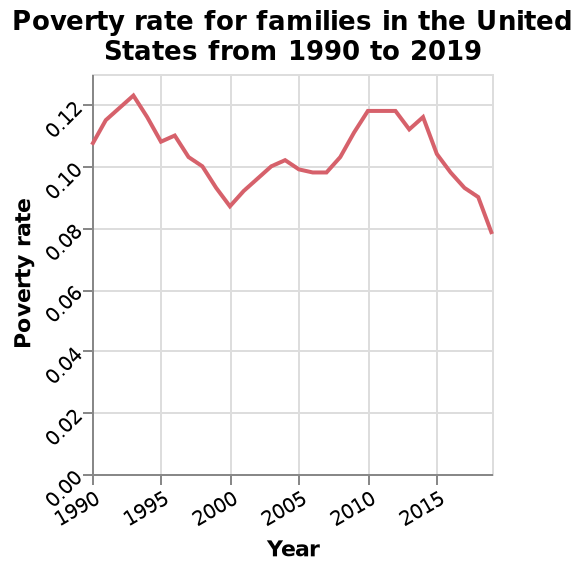<image>
What type of chart is used to represent the data? The data is represented using a line chart. When was poverty in the USA at its highest?  Poverty in the USA was at its highest in the early nineties. In which year did poverty in the USA drop to its second lowest point on the chart?  Poverty in the USA dropped to its second lowest point on the chart in 2000. 